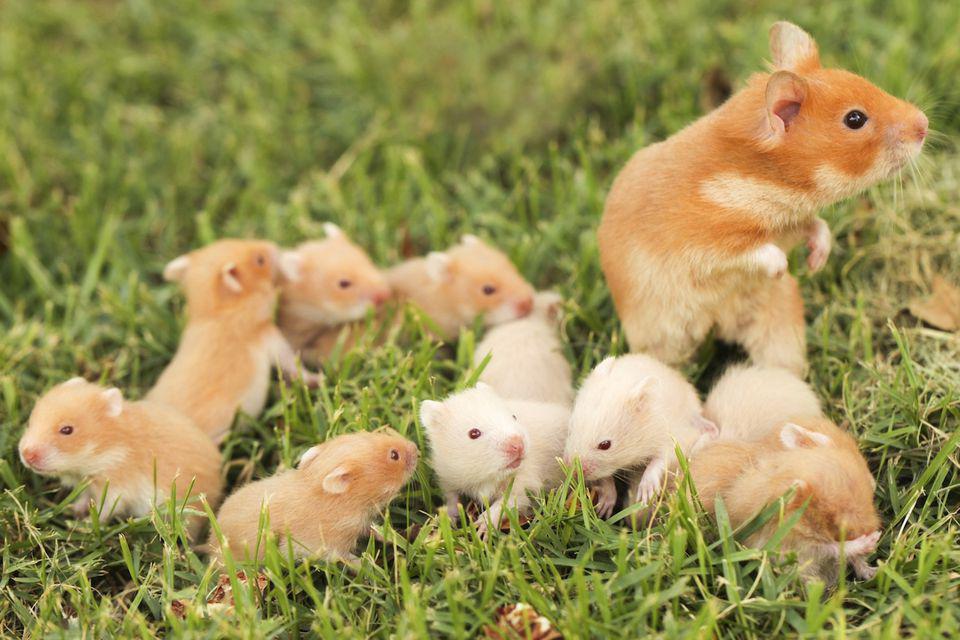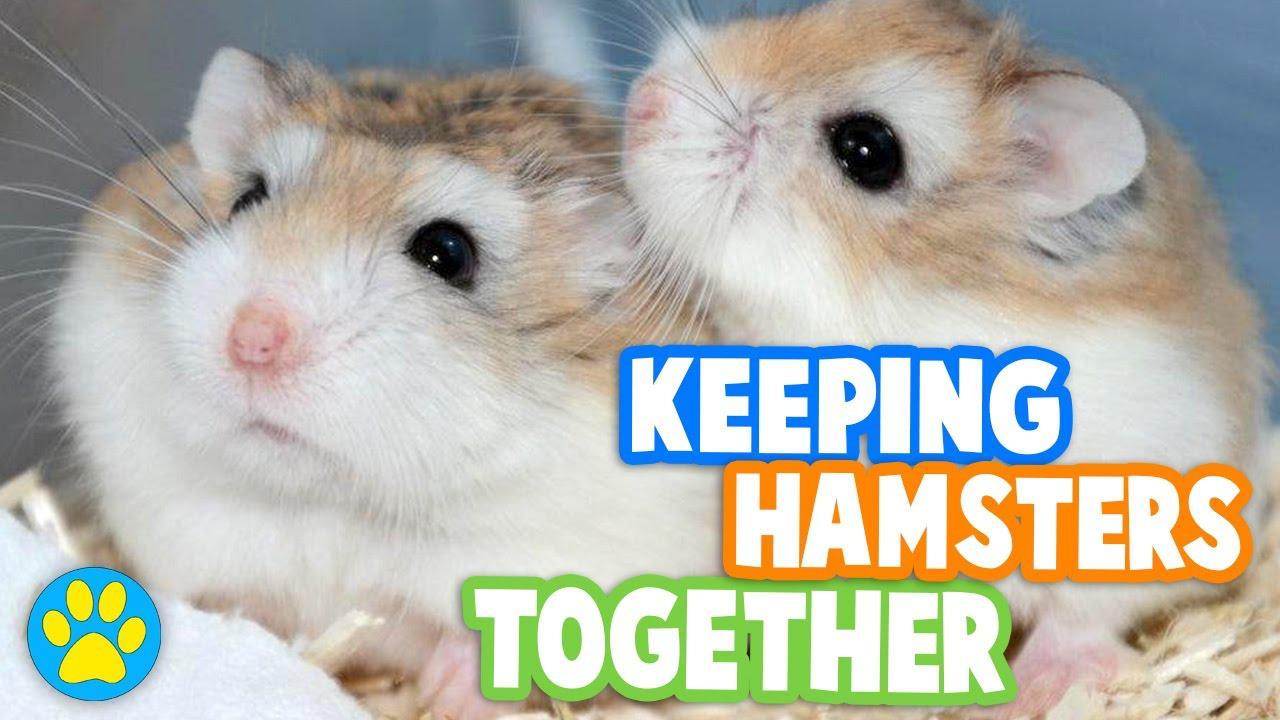The first image is the image on the left, the second image is the image on the right. Examine the images to the left and right. Is the description "The left image contains at least seven rodents." accurate? Answer yes or no. Yes. The first image is the image on the left, the second image is the image on the right. Evaluate the accuracy of this statement regarding the images: "At least one animal is outside.". Is it true? Answer yes or no. Yes. 